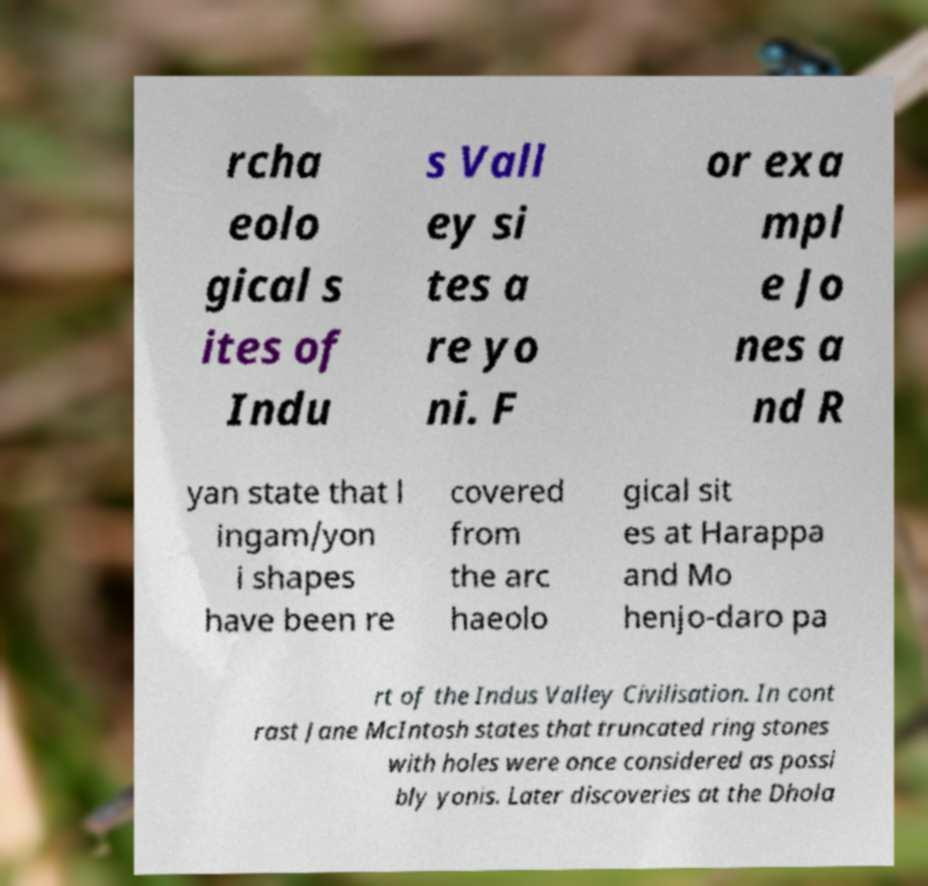I need the written content from this picture converted into text. Can you do that? rcha eolo gical s ites of Indu s Vall ey si tes a re yo ni. F or exa mpl e Jo nes a nd R yan state that l ingam/yon i shapes have been re covered from the arc haeolo gical sit es at Harappa and Mo henjo-daro pa rt of the Indus Valley Civilisation. In cont rast Jane McIntosh states that truncated ring stones with holes were once considered as possi bly yonis. Later discoveries at the Dhola 